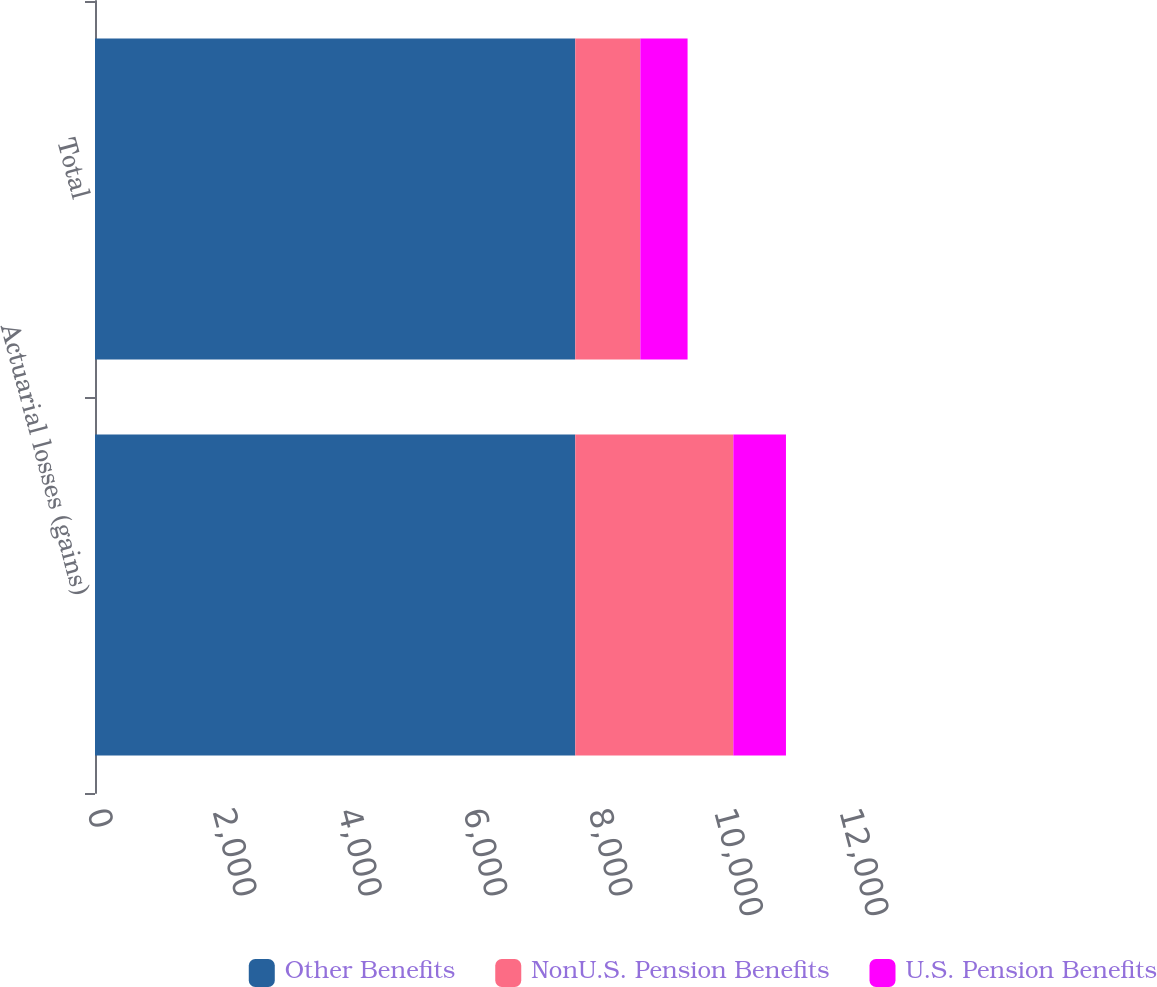Convert chart to OTSL. <chart><loc_0><loc_0><loc_500><loc_500><stacked_bar_chart><ecel><fcel>Actuarial losses (gains)<fcel>Total<nl><fcel>Other Benefits<fcel>7664<fcel>7664<nl><fcel>NonU.S. Pension Benefits<fcel>2522<fcel>1038<nl><fcel>U.S. Pension Benefits<fcel>840<fcel>754<nl></chart> 